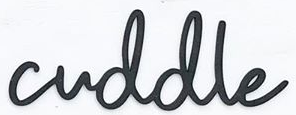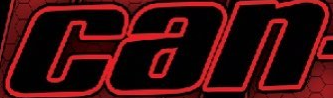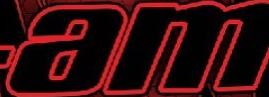Read the text from these images in sequence, separated by a semicolon. cuddle; can; am 